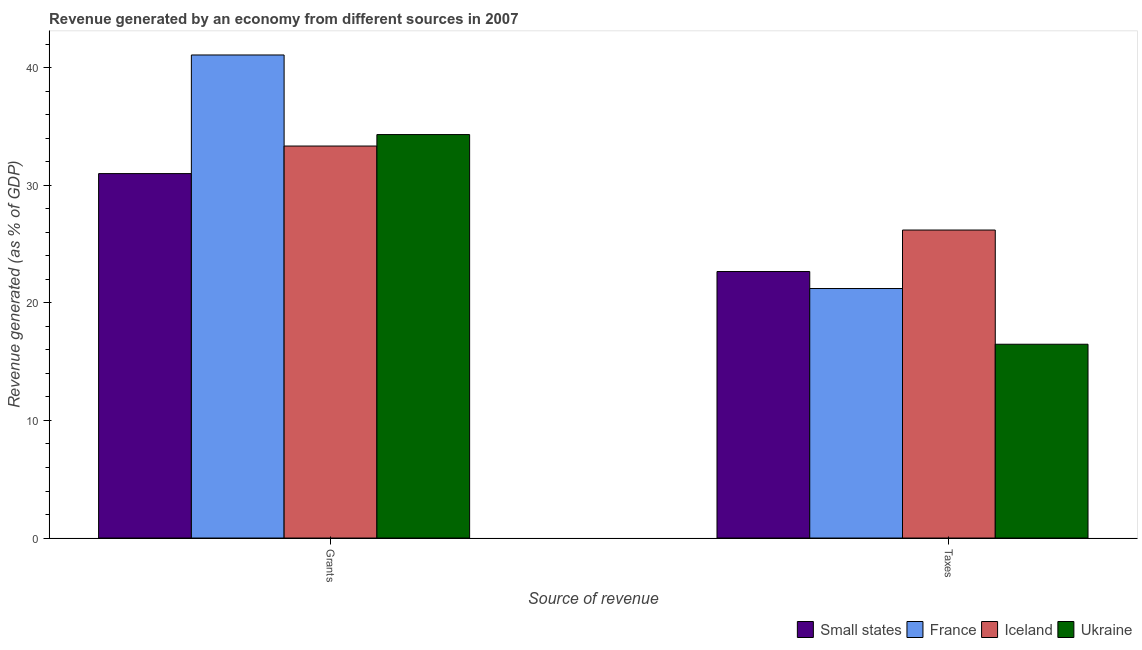Are the number of bars per tick equal to the number of legend labels?
Your answer should be very brief. Yes. Are the number of bars on each tick of the X-axis equal?
Make the answer very short. Yes. How many bars are there on the 2nd tick from the left?
Your answer should be compact. 4. What is the label of the 2nd group of bars from the left?
Provide a succinct answer. Taxes. What is the revenue generated by taxes in Iceland?
Ensure brevity in your answer.  26.2. Across all countries, what is the maximum revenue generated by taxes?
Provide a short and direct response. 26.2. Across all countries, what is the minimum revenue generated by grants?
Your answer should be very brief. 31. In which country was the revenue generated by taxes minimum?
Make the answer very short. Ukraine. What is the total revenue generated by grants in the graph?
Keep it short and to the point. 139.76. What is the difference between the revenue generated by taxes in France and that in Small states?
Keep it short and to the point. -1.45. What is the difference between the revenue generated by taxes in Ukraine and the revenue generated by grants in Small states?
Offer a very short reply. -14.52. What is the average revenue generated by taxes per country?
Provide a succinct answer. 21.65. What is the difference between the revenue generated by grants and revenue generated by taxes in Iceland?
Give a very brief answer. 7.15. What is the ratio of the revenue generated by grants in France to that in Iceland?
Make the answer very short. 1.23. Is the revenue generated by grants in Ukraine less than that in Iceland?
Make the answer very short. No. In how many countries, is the revenue generated by grants greater than the average revenue generated by grants taken over all countries?
Provide a short and direct response. 1. What does the 4th bar from the left in Grants represents?
Provide a succinct answer. Ukraine. What does the 1st bar from the right in Taxes represents?
Your answer should be compact. Ukraine. Are all the bars in the graph horizontal?
Ensure brevity in your answer.  No. How many countries are there in the graph?
Offer a terse response. 4. Are the values on the major ticks of Y-axis written in scientific E-notation?
Your answer should be very brief. No. Does the graph contain any zero values?
Offer a very short reply. No. Does the graph contain grids?
Keep it short and to the point. No. How many legend labels are there?
Your response must be concise. 4. What is the title of the graph?
Make the answer very short. Revenue generated by an economy from different sources in 2007. Does "New Zealand" appear as one of the legend labels in the graph?
Offer a very short reply. No. What is the label or title of the X-axis?
Give a very brief answer. Source of revenue. What is the label or title of the Y-axis?
Keep it short and to the point. Revenue generated (as % of GDP). What is the Revenue generated (as % of GDP) in Small states in Grants?
Provide a short and direct response. 31. What is the Revenue generated (as % of GDP) of France in Grants?
Your response must be concise. 41.09. What is the Revenue generated (as % of GDP) in Iceland in Grants?
Offer a very short reply. 33.34. What is the Revenue generated (as % of GDP) of Ukraine in Grants?
Offer a terse response. 34.32. What is the Revenue generated (as % of GDP) of Small states in Taxes?
Ensure brevity in your answer.  22.67. What is the Revenue generated (as % of GDP) of France in Taxes?
Make the answer very short. 21.22. What is the Revenue generated (as % of GDP) in Iceland in Taxes?
Your answer should be very brief. 26.2. What is the Revenue generated (as % of GDP) of Ukraine in Taxes?
Offer a terse response. 16.48. Across all Source of revenue, what is the maximum Revenue generated (as % of GDP) in Small states?
Give a very brief answer. 31. Across all Source of revenue, what is the maximum Revenue generated (as % of GDP) of France?
Your answer should be very brief. 41.09. Across all Source of revenue, what is the maximum Revenue generated (as % of GDP) in Iceland?
Offer a terse response. 33.34. Across all Source of revenue, what is the maximum Revenue generated (as % of GDP) of Ukraine?
Provide a succinct answer. 34.32. Across all Source of revenue, what is the minimum Revenue generated (as % of GDP) in Small states?
Give a very brief answer. 22.67. Across all Source of revenue, what is the minimum Revenue generated (as % of GDP) of France?
Make the answer very short. 21.22. Across all Source of revenue, what is the minimum Revenue generated (as % of GDP) of Iceland?
Ensure brevity in your answer.  26.2. Across all Source of revenue, what is the minimum Revenue generated (as % of GDP) of Ukraine?
Give a very brief answer. 16.48. What is the total Revenue generated (as % of GDP) in Small states in the graph?
Offer a terse response. 53.67. What is the total Revenue generated (as % of GDP) in France in the graph?
Offer a terse response. 62.32. What is the total Revenue generated (as % of GDP) in Iceland in the graph?
Provide a short and direct response. 59.54. What is the total Revenue generated (as % of GDP) of Ukraine in the graph?
Keep it short and to the point. 50.8. What is the difference between the Revenue generated (as % of GDP) of Small states in Grants and that in Taxes?
Offer a terse response. 8.33. What is the difference between the Revenue generated (as % of GDP) of France in Grants and that in Taxes?
Offer a very short reply. 19.87. What is the difference between the Revenue generated (as % of GDP) of Iceland in Grants and that in Taxes?
Provide a short and direct response. 7.14. What is the difference between the Revenue generated (as % of GDP) of Ukraine in Grants and that in Taxes?
Provide a short and direct response. 17.84. What is the difference between the Revenue generated (as % of GDP) in Small states in Grants and the Revenue generated (as % of GDP) in France in Taxes?
Offer a very short reply. 9.78. What is the difference between the Revenue generated (as % of GDP) in Small states in Grants and the Revenue generated (as % of GDP) in Iceland in Taxes?
Provide a succinct answer. 4.8. What is the difference between the Revenue generated (as % of GDP) of Small states in Grants and the Revenue generated (as % of GDP) of Ukraine in Taxes?
Ensure brevity in your answer.  14.52. What is the difference between the Revenue generated (as % of GDP) in France in Grants and the Revenue generated (as % of GDP) in Iceland in Taxes?
Offer a very short reply. 14.89. What is the difference between the Revenue generated (as % of GDP) of France in Grants and the Revenue generated (as % of GDP) of Ukraine in Taxes?
Provide a succinct answer. 24.61. What is the difference between the Revenue generated (as % of GDP) of Iceland in Grants and the Revenue generated (as % of GDP) of Ukraine in Taxes?
Give a very brief answer. 16.86. What is the average Revenue generated (as % of GDP) of Small states per Source of revenue?
Ensure brevity in your answer.  26.84. What is the average Revenue generated (as % of GDP) in France per Source of revenue?
Your answer should be compact. 31.16. What is the average Revenue generated (as % of GDP) in Iceland per Source of revenue?
Provide a short and direct response. 29.77. What is the average Revenue generated (as % of GDP) in Ukraine per Source of revenue?
Your answer should be compact. 25.4. What is the difference between the Revenue generated (as % of GDP) of Small states and Revenue generated (as % of GDP) of France in Grants?
Give a very brief answer. -10.09. What is the difference between the Revenue generated (as % of GDP) of Small states and Revenue generated (as % of GDP) of Iceland in Grants?
Provide a succinct answer. -2.34. What is the difference between the Revenue generated (as % of GDP) of Small states and Revenue generated (as % of GDP) of Ukraine in Grants?
Provide a succinct answer. -3.32. What is the difference between the Revenue generated (as % of GDP) in France and Revenue generated (as % of GDP) in Iceland in Grants?
Offer a very short reply. 7.75. What is the difference between the Revenue generated (as % of GDP) in France and Revenue generated (as % of GDP) in Ukraine in Grants?
Keep it short and to the point. 6.77. What is the difference between the Revenue generated (as % of GDP) in Iceland and Revenue generated (as % of GDP) in Ukraine in Grants?
Keep it short and to the point. -0.98. What is the difference between the Revenue generated (as % of GDP) of Small states and Revenue generated (as % of GDP) of France in Taxes?
Keep it short and to the point. 1.45. What is the difference between the Revenue generated (as % of GDP) in Small states and Revenue generated (as % of GDP) in Iceland in Taxes?
Give a very brief answer. -3.53. What is the difference between the Revenue generated (as % of GDP) of Small states and Revenue generated (as % of GDP) of Ukraine in Taxes?
Provide a succinct answer. 6.19. What is the difference between the Revenue generated (as % of GDP) of France and Revenue generated (as % of GDP) of Iceland in Taxes?
Provide a succinct answer. -4.98. What is the difference between the Revenue generated (as % of GDP) in France and Revenue generated (as % of GDP) in Ukraine in Taxes?
Give a very brief answer. 4.74. What is the difference between the Revenue generated (as % of GDP) of Iceland and Revenue generated (as % of GDP) of Ukraine in Taxes?
Keep it short and to the point. 9.72. What is the ratio of the Revenue generated (as % of GDP) of Small states in Grants to that in Taxes?
Provide a short and direct response. 1.37. What is the ratio of the Revenue generated (as % of GDP) of France in Grants to that in Taxes?
Your answer should be compact. 1.94. What is the ratio of the Revenue generated (as % of GDP) in Iceland in Grants to that in Taxes?
Ensure brevity in your answer.  1.27. What is the ratio of the Revenue generated (as % of GDP) in Ukraine in Grants to that in Taxes?
Provide a short and direct response. 2.08. What is the difference between the highest and the second highest Revenue generated (as % of GDP) in Small states?
Your answer should be very brief. 8.33. What is the difference between the highest and the second highest Revenue generated (as % of GDP) of France?
Ensure brevity in your answer.  19.87. What is the difference between the highest and the second highest Revenue generated (as % of GDP) in Iceland?
Offer a terse response. 7.14. What is the difference between the highest and the second highest Revenue generated (as % of GDP) in Ukraine?
Your answer should be very brief. 17.84. What is the difference between the highest and the lowest Revenue generated (as % of GDP) of Small states?
Keep it short and to the point. 8.33. What is the difference between the highest and the lowest Revenue generated (as % of GDP) in France?
Provide a succinct answer. 19.87. What is the difference between the highest and the lowest Revenue generated (as % of GDP) in Iceland?
Keep it short and to the point. 7.14. What is the difference between the highest and the lowest Revenue generated (as % of GDP) in Ukraine?
Offer a terse response. 17.84. 